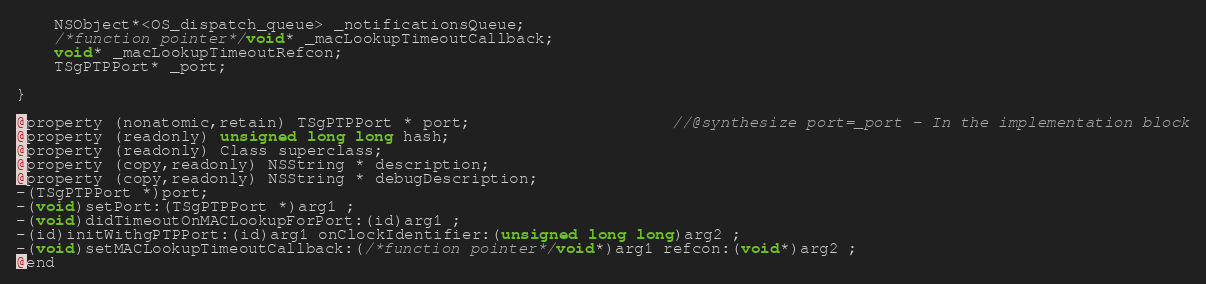Convert code to text. <code><loc_0><loc_0><loc_500><loc_500><_C_>
	NSObject*<OS_dispatch_queue> _notificationsQueue;
	/*function pointer*/void* _macLookupTimeoutCallback;
	void* _macLookupTimeoutRefcon;
	TSgPTPPort* _port;

}

@property (nonatomic,retain) TSgPTPPort * port;                     //@synthesize port=_port - In the implementation block
@property (readonly) unsigned long long hash; 
@property (readonly) Class superclass; 
@property (copy,readonly) NSString * description; 
@property (copy,readonly) NSString * debugDescription; 
-(TSgPTPPort *)port;
-(void)setPort:(TSgPTPPort *)arg1 ;
-(void)didTimeoutOnMACLookupForPort:(id)arg1 ;
-(id)initWithgPTPPort:(id)arg1 onClockIdentifier:(unsigned long long)arg2 ;
-(void)setMACLookupTimeoutCallback:(/*function pointer*/void*)arg1 refcon:(void*)arg2 ;
@end

</code> 